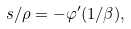Convert formula to latex. <formula><loc_0><loc_0><loc_500><loc_500>s / \rho = - \varphi ^ { \prime } ( 1 / \beta ) ,</formula> 